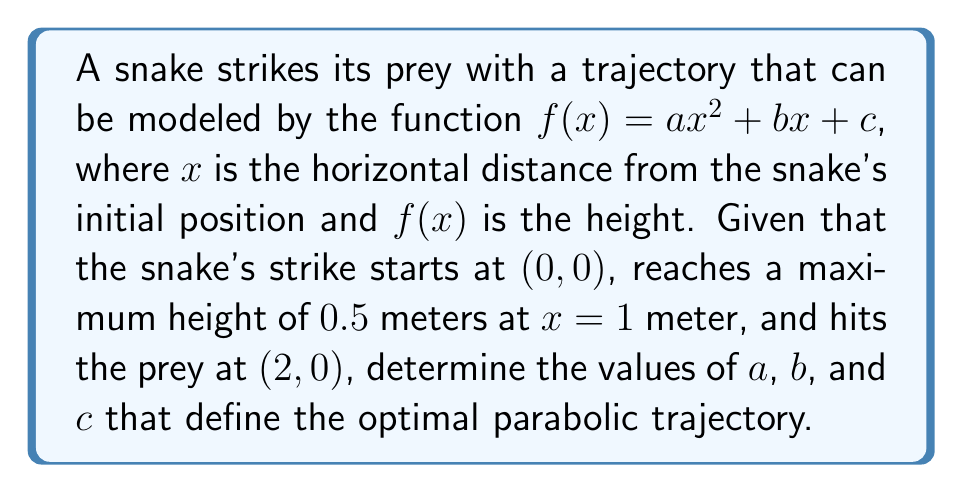Help me with this question. 1) We know three points on the parabola:
   (0, 0), (1, 0.5), and (2, 0)

2) Let's use these points to set up three equations:
   $f(0) = c = 0$
   $f(1) = a + b + c = 0.5$
   $f(2) = 4a + 2b + c = 0$

3) From the first equation, we know that $c = 0$

4) Substituting this into the other two equations:
   $a + b = 0.5$
   $4a + 2b = 0$

5) Multiply the first equation by 2:
   $2a + 2b = 1$
   $4a + 2b = 0$

6) Subtract the second equation from the first:
   $-2a = 1$
   $a = -0.5$

7) Substitute this back into $a + b = 0.5$:
   $-0.5 + b = 0.5$
   $b = 1$

8) Therefore, the optimal trajectory is defined by:
   $f(x) = -0.5x^2 + x$

9) Verify: 
   $f(0) = 0$
   $f(1) = -0.5 + 1 = 0.5$
   $f(2) = -2 + 2 = 0$
Answer: $a = -0.5$, $b = 1$, $c = 0$ 